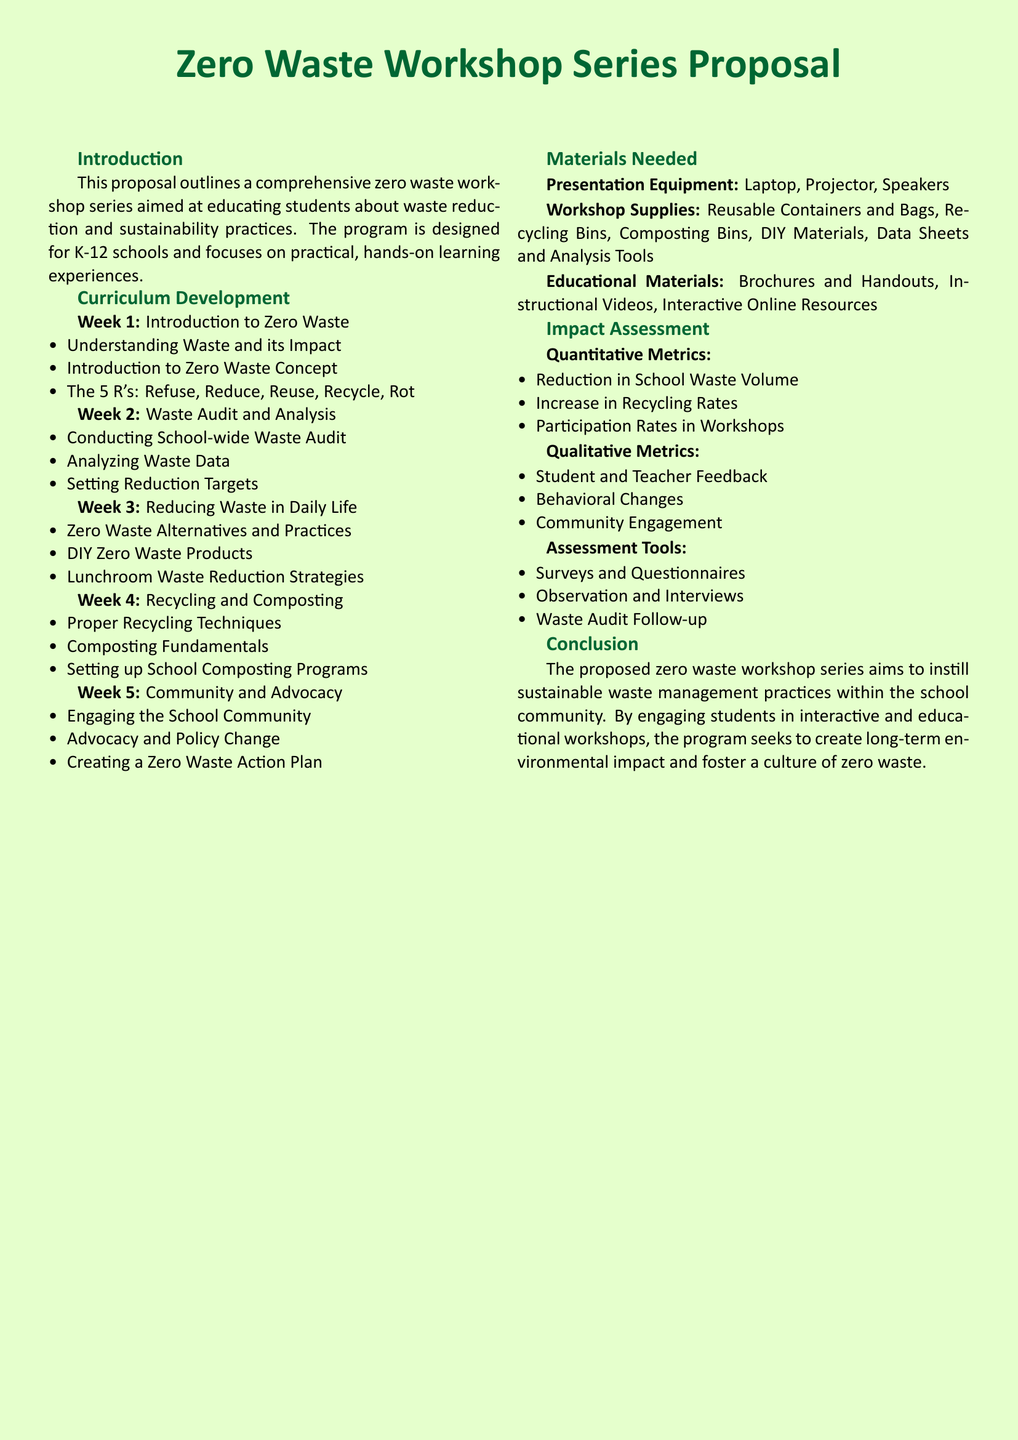What is the main goal of the workshop series? The main goal is to educate students about waste reduction and sustainability practices.
Answer: Educate students about waste reduction and sustainability practices What are the 5 R's introduced in Week 1? The 5 R's are Refuse, Reduce, Reuse, Recycle, and Rot, which are outlined in the workshop curriculum.
Answer: Refuse, Reduce, Reuse, Recycle, Rot Which week focuses on Recycling and Composting? The workshop curriculum specifies that Week 4 is dedicated to Recycling and Composting.
Answer: Week 4 What type of materials are needed for the workshops? The proposal lists presentation equipment, workshop supplies, and educational materials as necessary items for the workshops.
Answer: Presentation equipment, workshop supplies, educational materials How will the impact of the workshop be assessed? The impact will be assessed through qualitative metrics such as feedback, behavioral changes, and community engagement, in addition to quantitative metrics.
Answer: Through qualitative and quantitative metrics 